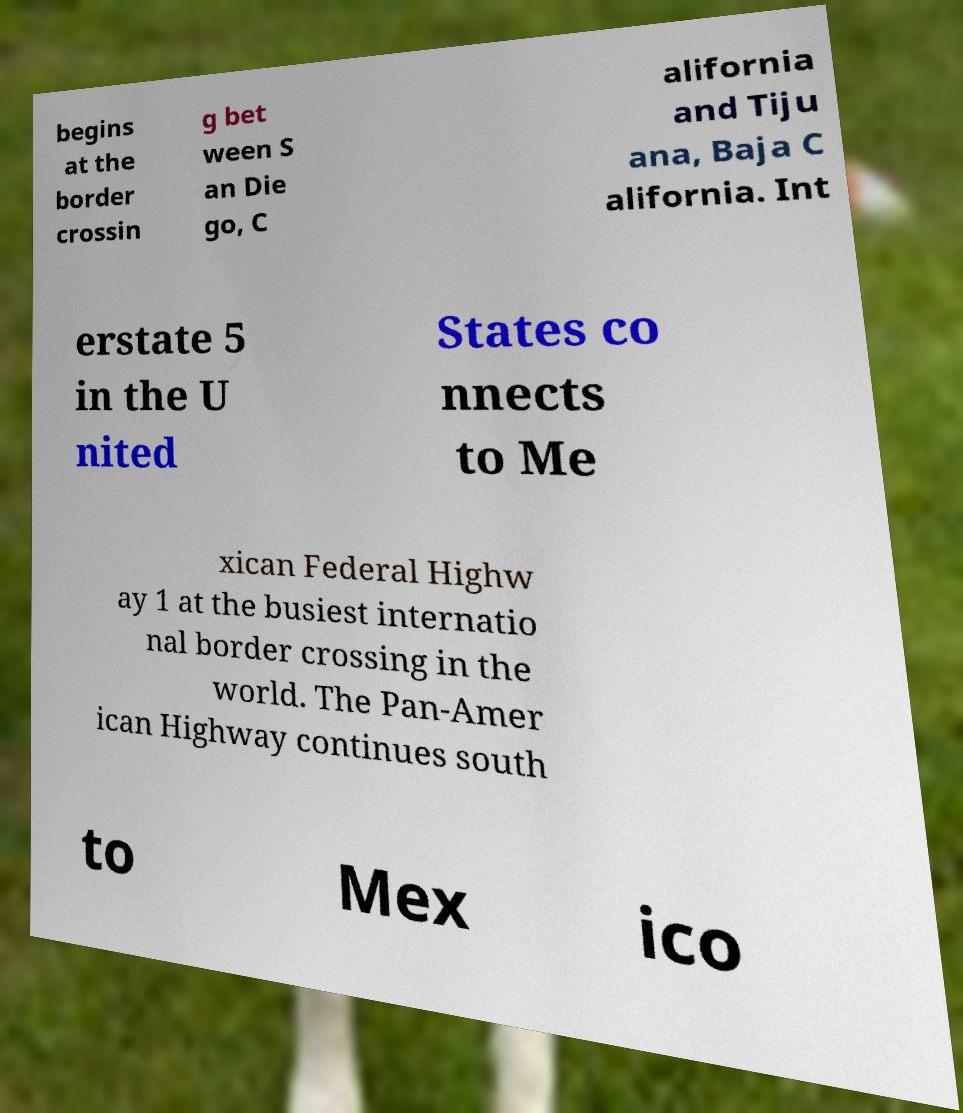Could you extract and type out the text from this image? begins at the border crossin g bet ween S an Die go, C alifornia and Tiju ana, Baja C alifornia. Int erstate 5 in the U nited States co nnects to Me xican Federal Highw ay 1 at the busiest internatio nal border crossing in the world. The Pan-Amer ican Highway continues south to Mex ico 